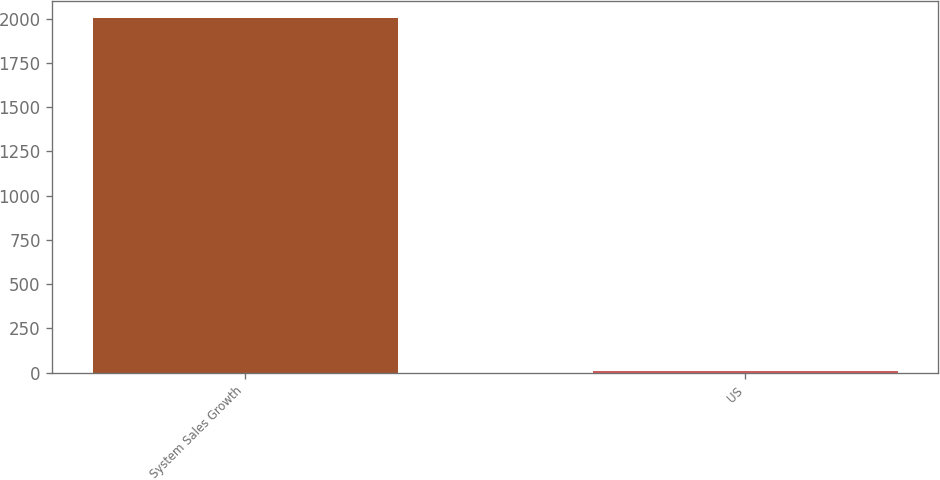<chart> <loc_0><loc_0><loc_500><loc_500><bar_chart><fcel>System Sales Growth<fcel>US<nl><fcel>2002<fcel>9<nl></chart> 